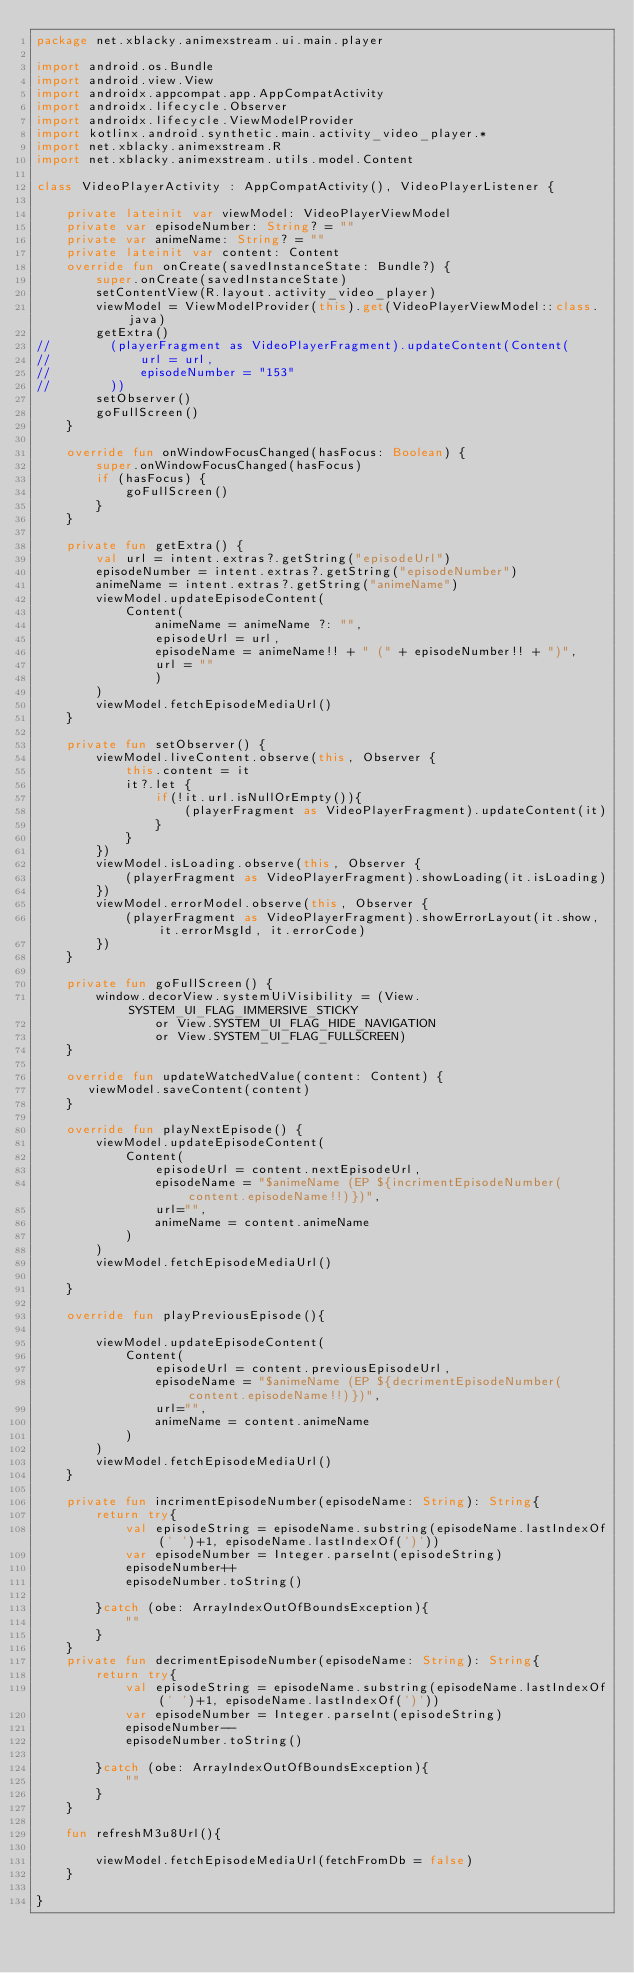Convert code to text. <code><loc_0><loc_0><loc_500><loc_500><_Kotlin_>package net.xblacky.animexstream.ui.main.player

import android.os.Bundle
import android.view.View
import androidx.appcompat.app.AppCompatActivity
import androidx.lifecycle.Observer
import androidx.lifecycle.ViewModelProvider
import kotlinx.android.synthetic.main.activity_video_player.*
import net.xblacky.animexstream.R
import net.xblacky.animexstream.utils.model.Content

class VideoPlayerActivity : AppCompatActivity(), VideoPlayerListener {

    private lateinit var viewModel: VideoPlayerViewModel
    private var episodeNumber: String? = ""
    private var animeName: String? = ""
    private lateinit var content: Content
    override fun onCreate(savedInstanceState: Bundle?) {
        super.onCreate(savedInstanceState)
        setContentView(R.layout.activity_video_player)
        viewModel = ViewModelProvider(this).get(VideoPlayerViewModel::class.java)
        getExtra()
//        (playerFragment as VideoPlayerFragment).updateContent(Content(
//            url = url,
//            episodeNumber = "153"
//        ))
        setObserver()
        goFullScreen()
    }

    override fun onWindowFocusChanged(hasFocus: Boolean) {
        super.onWindowFocusChanged(hasFocus)
        if (hasFocus) {
            goFullScreen()
        }
    }

    private fun getExtra() {
        val url = intent.extras?.getString("episodeUrl")
        episodeNumber = intent.extras?.getString("episodeNumber")
        animeName = intent.extras?.getString("animeName")
        viewModel.updateEpisodeContent(
            Content(
                animeName = animeName ?: "",
                episodeUrl = url,
                episodeName = animeName!! + " (" + episodeNumber!! + ")",
                url = ""
                )
        )
        viewModel.fetchEpisodeMediaUrl()
    }

    private fun setObserver() {
        viewModel.liveContent.observe(this, Observer {
            this.content = it
            it?.let {
                if(!it.url.isNullOrEmpty()){
                    (playerFragment as VideoPlayerFragment).updateContent(it)
                }
            }
        })
        viewModel.isLoading.observe(this, Observer {
            (playerFragment as VideoPlayerFragment).showLoading(it.isLoading)
        })
        viewModel.errorModel.observe(this, Observer {
            (playerFragment as VideoPlayerFragment).showErrorLayout(it.show, it.errorMsgId, it.errorCode)
        })
    }

    private fun goFullScreen() {
        window.decorView.systemUiVisibility = (View.SYSTEM_UI_FLAG_IMMERSIVE_STICKY
                or View.SYSTEM_UI_FLAG_HIDE_NAVIGATION
                or View.SYSTEM_UI_FLAG_FULLSCREEN)
    }

    override fun updateWatchedValue(content: Content) {
       viewModel.saveContent(content)
    }

    override fun playNextEpisode() {
        viewModel.updateEpisodeContent(
            Content(
                episodeUrl = content.nextEpisodeUrl,
                episodeName = "$animeName (EP ${incrimentEpisodeNumber(content.episodeName!!)})",
                url="",
                animeName = content.animeName
            )
        )
        viewModel.fetchEpisodeMediaUrl()

    }

    override fun playPreviousEpisode(){

        viewModel.updateEpisodeContent(
            Content(
                episodeUrl = content.previousEpisodeUrl,
                episodeName = "$animeName (EP ${decrimentEpisodeNumber(content.episodeName!!)})",
                url="",
                animeName = content.animeName
            )
        )
        viewModel.fetchEpisodeMediaUrl()
    }

    private fun incrimentEpisodeNumber(episodeName: String): String{
        return try{
            val episodeString = episodeName.substring(episodeName.lastIndexOf(' ')+1, episodeName.lastIndexOf(')'))
            var episodeNumber = Integer.parseInt(episodeString)
            episodeNumber++
            episodeNumber.toString()

        }catch (obe: ArrayIndexOutOfBoundsException){
            ""
        }
    }
    private fun decrimentEpisodeNumber(episodeName: String): String{
        return try{
            val episodeString = episodeName.substring(episodeName.lastIndexOf(' ')+1, episodeName.lastIndexOf(')'))
            var episodeNumber = Integer.parseInt(episodeString)
            episodeNumber--
            episodeNumber.toString()

        }catch (obe: ArrayIndexOutOfBoundsException){
            ""
        }
    }

    fun refreshM3u8Url(){

        viewModel.fetchEpisodeMediaUrl(fetchFromDb = false)
    }

}</code> 